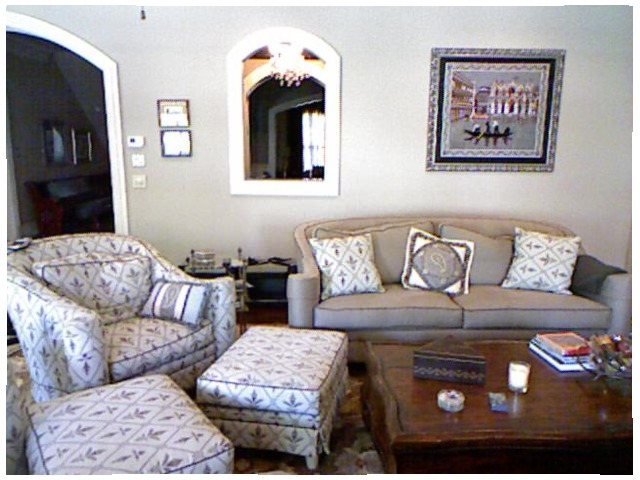<image>
Is the mirror under the table? No. The mirror is not positioned under the table. The vertical relationship between these objects is different. Where is the table in relation to the sofa? Is it in front of the sofa? Yes. The table is positioned in front of the sofa, appearing closer to the camera viewpoint. Where is the box in relation to the table? Is it in front of the table? No. The box is not in front of the table. The spatial positioning shows a different relationship between these objects. Where is the frame in relation to the wall? Is it on the wall? Yes. Looking at the image, I can see the frame is positioned on top of the wall, with the wall providing support. Is there a pillow on the chair? No. The pillow is not positioned on the chair. They may be near each other, but the pillow is not supported by or resting on top of the chair. 